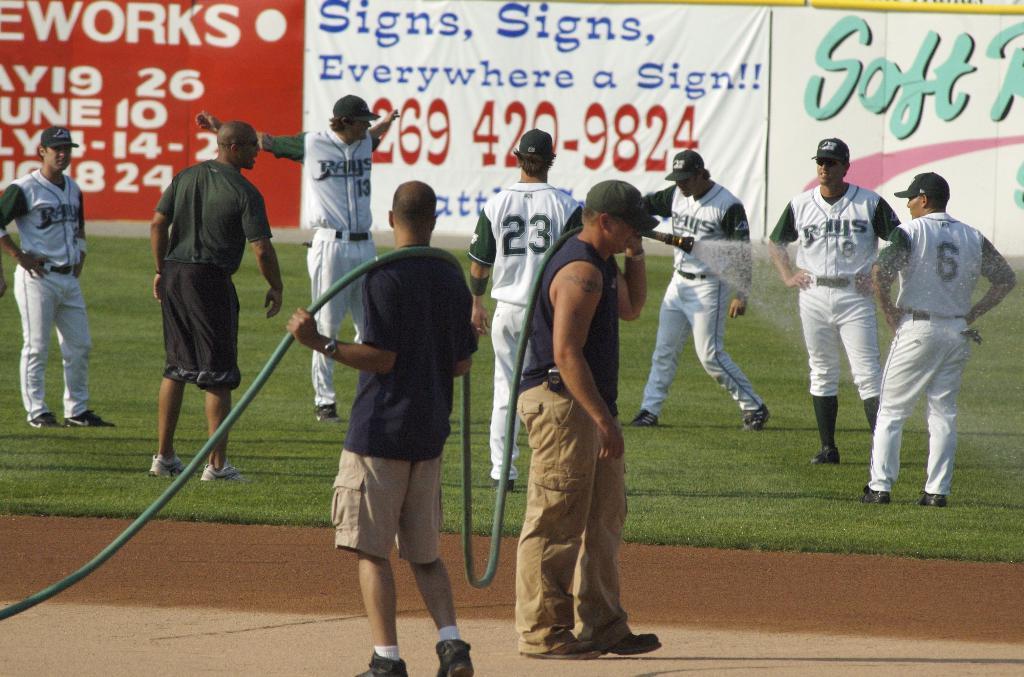What number should i call?
Keep it short and to the point. 269-420-9824. What is the player on the rights jersey number?
Make the answer very short. 6. 